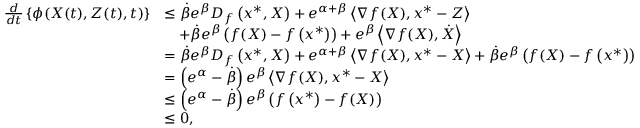Convert formula to latex. <formula><loc_0><loc_0><loc_500><loc_500>\begin{array} { r l } { \frac { d } { d t } \left \{ \phi ( X ( t ) , Z ( t ) , t ) \right \} } & { \leq \dot { \beta } e ^ { \beta } D _ { f } \left ( x ^ { * } , X \right ) + e ^ { \alpha + \beta } \left \langle \nabla f ( X ) , x ^ { * } - Z \right \rangle } \\ & { \quad + \dot { \beta } e ^ { \beta } \left ( f ( X ) - f \left ( x ^ { * } \right ) \right ) + e ^ { \beta } \left \langle \nabla f ( X ) , \dot { X } \right \rangle } \\ & { = \dot { \beta } e ^ { \beta } D _ { f } \left ( x ^ { * } , X \right ) + e ^ { \alpha + \beta } \left \langle \nabla f ( X ) , x ^ { * } - X \right \rangle + \dot { \beta } e ^ { \beta } \left ( f ( X ) - f \left ( x ^ { * } \right ) \right ) } \\ & { = \left ( e ^ { \alpha } - \dot { \beta } \right ) e ^ { \beta } \left \langle \nabla f ( X ) , x ^ { * } - X \right \rangle } \\ & { \leq \left ( e ^ { \alpha } - \dot { \beta } \right ) e ^ { \beta } \left ( f \left ( x ^ { * } \right ) - f ( X ) \right ) } \\ & { \leq 0 , } \end{array}</formula> 